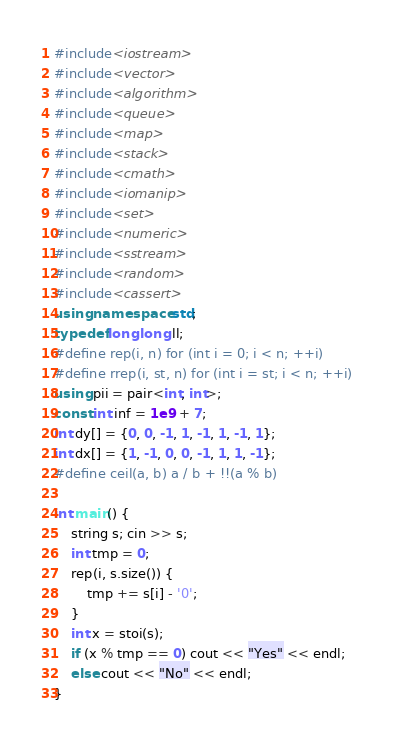<code> <loc_0><loc_0><loc_500><loc_500><_C++_>#include<iostream>
#include<vector>
#include<algorithm>
#include<queue>
#include<map>
#include<stack>
#include<cmath>
#include<iomanip>
#include<set>
#include<numeric>
#include<sstream>
#include<random>
#include<cassert>
using namespace std;
typedef long long ll;
#define rep(i, n) for (int i = 0; i < n; ++i)
#define rrep(i, st, n) for (int i = st; i < n; ++i)
using pii = pair<int, int>;
const int inf = 1e9 + 7;
int dy[] = {0, 0, -1, 1, -1, 1, -1, 1};
int dx[] = {1, -1, 0, 0, -1, 1, 1, -1};
#define ceil(a, b) a / b + !!(a % b)

int main() {
    string s; cin >> s;
    int tmp = 0;
    rep(i, s.size()) {
        tmp += s[i] - '0';
    }
    int x = stoi(s);
    if (x % tmp == 0) cout << "Yes" << endl;
    else cout << "No" << endl;
}
</code> 